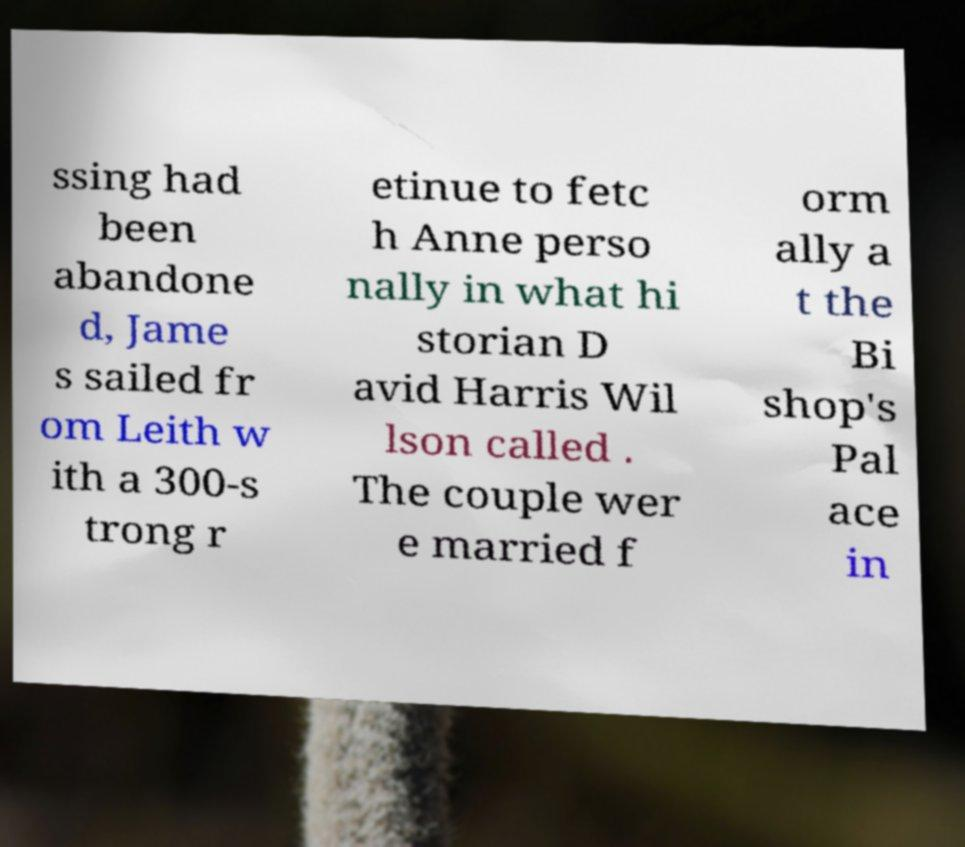Could you assist in decoding the text presented in this image and type it out clearly? ssing had been abandone d, Jame s sailed fr om Leith w ith a 300-s trong r etinue to fetc h Anne perso nally in what hi storian D avid Harris Wil lson called . The couple wer e married f orm ally a t the Bi shop's Pal ace in 